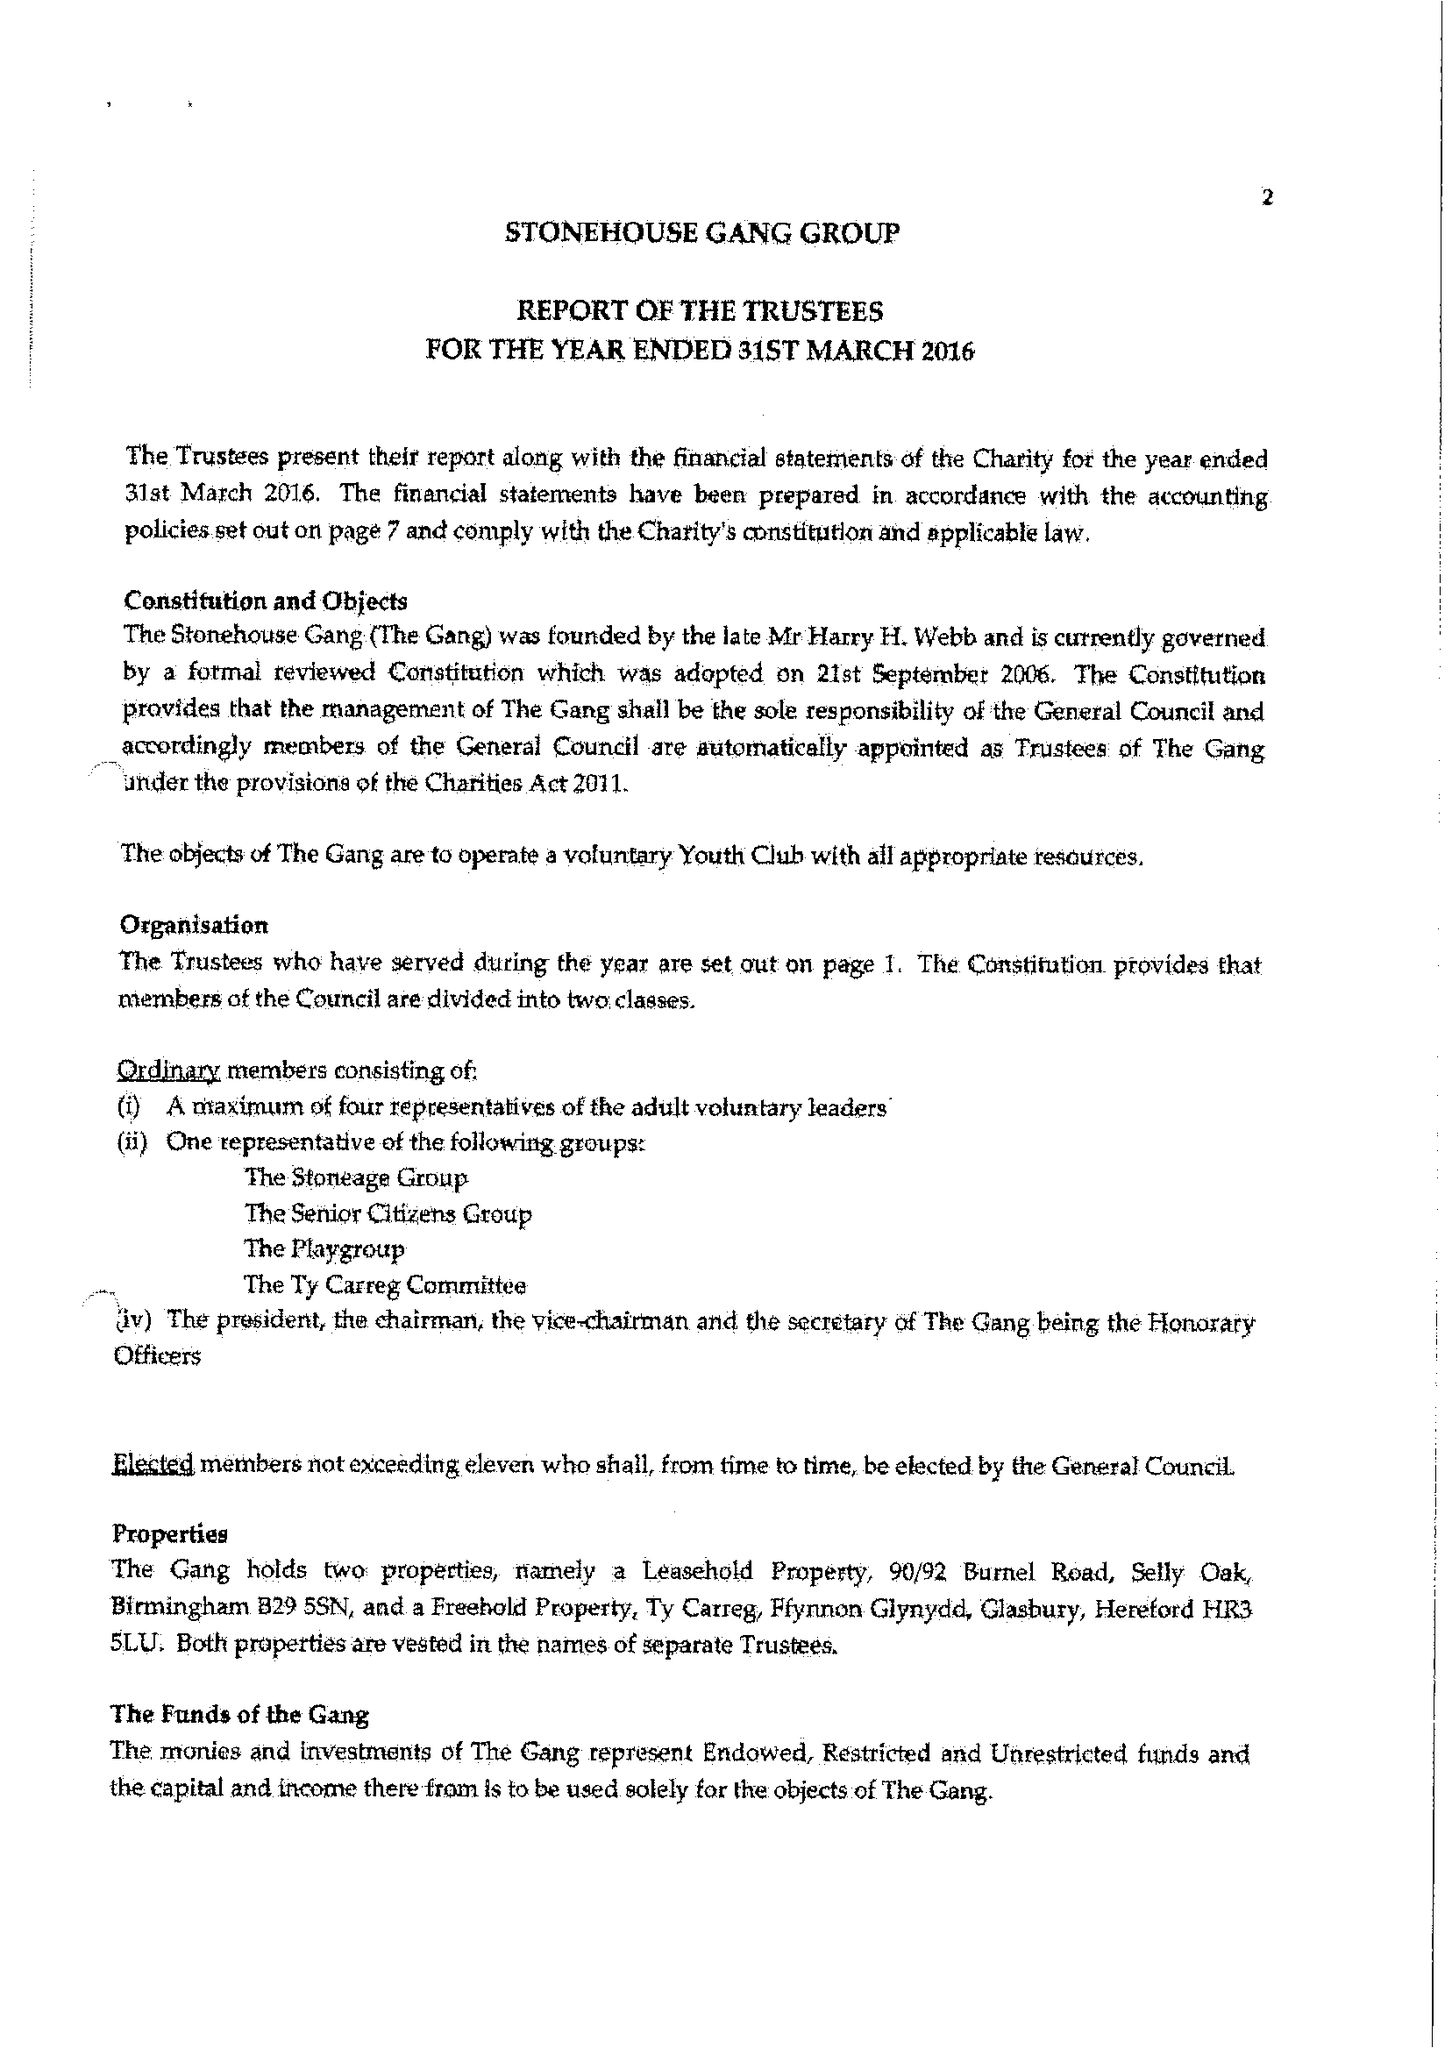What is the value for the spending_annually_in_british_pounds?
Answer the question using a single word or phrase. 144470.00 